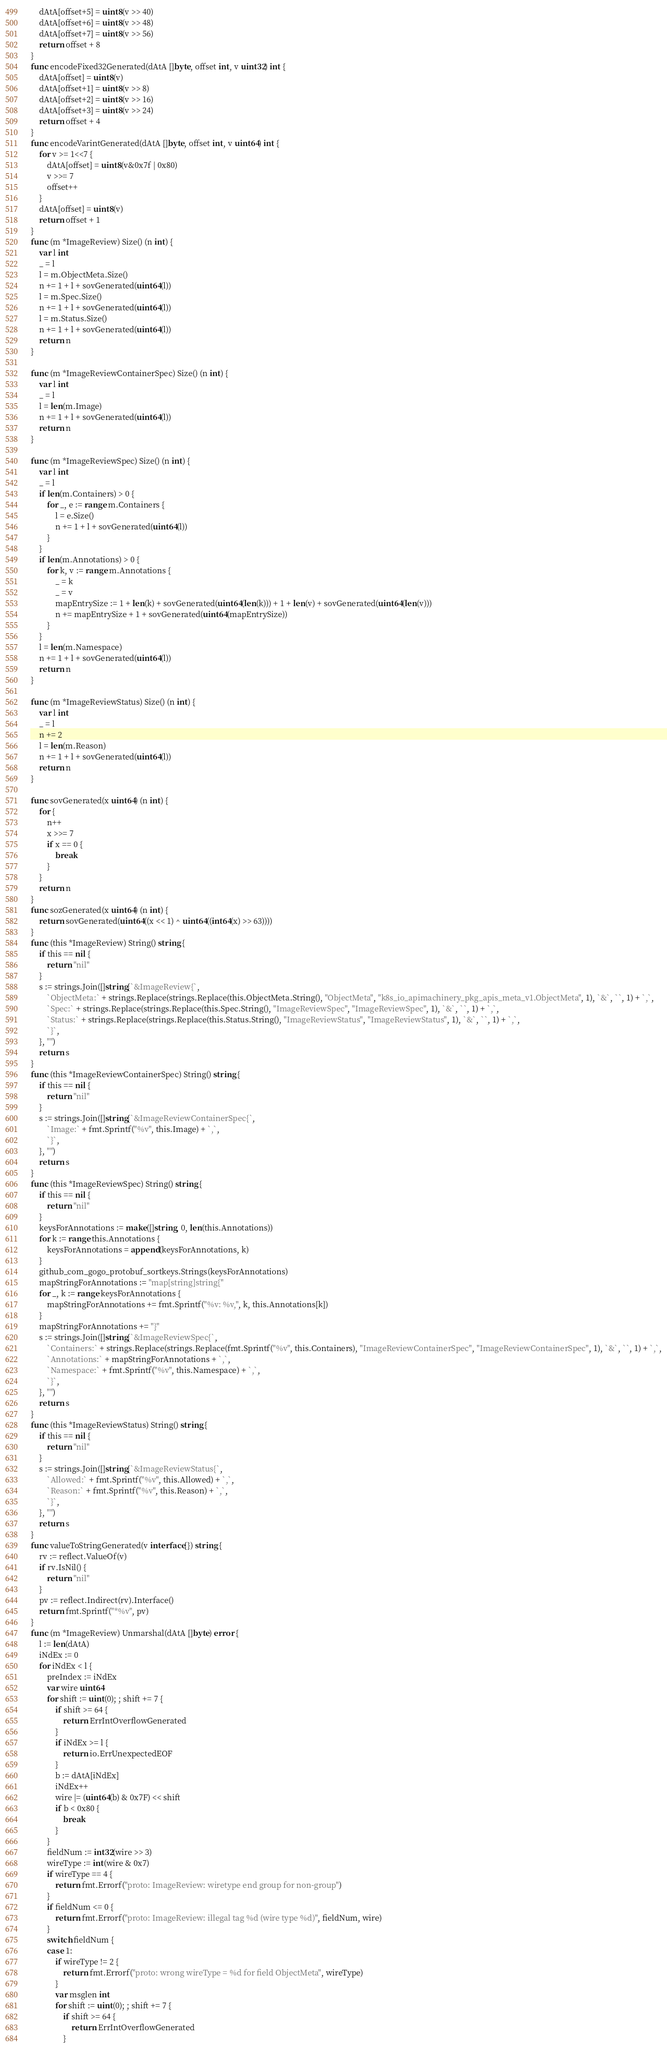<code> <loc_0><loc_0><loc_500><loc_500><_Go_>	dAtA[offset+5] = uint8(v >> 40)
	dAtA[offset+6] = uint8(v >> 48)
	dAtA[offset+7] = uint8(v >> 56)
	return offset + 8
}
func encodeFixed32Generated(dAtA []byte, offset int, v uint32) int {
	dAtA[offset] = uint8(v)
	dAtA[offset+1] = uint8(v >> 8)
	dAtA[offset+2] = uint8(v >> 16)
	dAtA[offset+3] = uint8(v >> 24)
	return offset + 4
}
func encodeVarintGenerated(dAtA []byte, offset int, v uint64) int {
	for v >= 1<<7 {
		dAtA[offset] = uint8(v&0x7f | 0x80)
		v >>= 7
		offset++
	}
	dAtA[offset] = uint8(v)
	return offset + 1
}
func (m *ImageReview) Size() (n int) {
	var l int
	_ = l
	l = m.ObjectMeta.Size()
	n += 1 + l + sovGenerated(uint64(l))
	l = m.Spec.Size()
	n += 1 + l + sovGenerated(uint64(l))
	l = m.Status.Size()
	n += 1 + l + sovGenerated(uint64(l))
	return n
}

func (m *ImageReviewContainerSpec) Size() (n int) {
	var l int
	_ = l
	l = len(m.Image)
	n += 1 + l + sovGenerated(uint64(l))
	return n
}

func (m *ImageReviewSpec) Size() (n int) {
	var l int
	_ = l
	if len(m.Containers) > 0 {
		for _, e := range m.Containers {
			l = e.Size()
			n += 1 + l + sovGenerated(uint64(l))
		}
	}
	if len(m.Annotations) > 0 {
		for k, v := range m.Annotations {
			_ = k
			_ = v
			mapEntrySize := 1 + len(k) + sovGenerated(uint64(len(k))) + 1 + len(v) + sovGenerated(uint64(len(v)))
			n += mapEntrySize + 1 + sovGenerated(uint64(mapEntrySize))
		}
	}
	l = len(m.Namespace)
	n += 1 + l + sovGenerated(uint64(l))
	return n
}

func (m *ImageReviewStatus) Size() (n int) {
	var l int
	_ = l
	n += 2
	l = len(m.Reason)
	n += 1 + l + sovGenerated(uint64(l))
	return n
}

func sovGenerated(x uint64) (n int) {
	for {
		n++
		x >>= 7
		if x == 0 {
			break
		}
	}
	return n
}
func sozGenerated(x uint64) (n int) {
	return sovGenerated(uint64((x << 1) ^ uint64((int64(x) >> 63))))
}
func (this *ImageReview) String() string {
	if this == nil {
		return "nil"
	}
	s := strings.Join([]string{`&ImageReview{`,
		`ObjectMeta:` + strings.Replace(strings.Replace(this.ObjectMeta.String(), "ObjectMeta", "k8s_io_apimachinery_pkg_apis_meta_v1.ObjectMeta", 1), `&`, ``, 1) + `,`,
		`Spec:` + strings.Replace(strings.Replace(this.Spec.String(), "ImageReviewSpec", "ImageReviewSpec", 1), `&`, ``, 1) + `,`,
		`Status:` + strings.Replace(strings.Replace(this.Status.String(), "ImageReviewStatus", "ImageReviewStatus", 1), `&`, ``, 1) + `,`,
		`}`,
	}, "")
	return s
}
func (this *ImageReviewContainerSpec) String() string {
	if this == nil {
		return "nil"
	}
	s := strings.Join([]string{`&ImageReviewContainerSpec{`,
		`Image:` + fmt.Sprintf("%v", this.Image) + `,`,
		`}`,
	}, "")
	return s
}
func (this *ImageReviewSpec) String() string {
	if this == nil {
		return "nil"
	}
	keysForAnnotations := make([]string, 0, len(this.Annotations))
	for k := range this.Annotations {
		keysForAnnotations = append(keysForAnnotations, k)
	}
	github_com_gogo_protobuf_sortkeys.Strings(keysForAnnotations)
	mapStringForAnnotations := "map[string]string{"
	for _, k := range keysForAnnotations {
		mapStringForAnnotations += fmt.Sprintf("%v: %v,", k, this.Annotations[k])
	}
	mapStringForAnnotations += "}"
	s := strings.Join([]string{`&ImageReviewSpec{`,
		`Containers:` + strings.Replace(strings.Replace(fmt.Sprintf("%v", this.Containers), "ImageReviewContainerSpec", "ImageReviewContainerSpec", 1), `&`, ``, 1) + `,`,
		`Annotations:` + mapStringForAnnotations + `,`,
		`Namespace:` + fmt.Sprintf("%v", this.Namespace) + `,`,
		`}`,
	}, "")
	return s
}
func (this *ImageReviewStatus) String() string {
	if this == nil {
		return "nil"
	}
	s := strings.Join([]string{`&ImageReviewStatus{`,
		`Allowed:` + fmt.Sprintf("%v", this.Allowed) + `,`,
		`Reason:` + fmt.Sprintf("%v", this.Reason) + `,`,
		`}`,
	}, "")
	return s
}
func valueToStringGenerated(v interface{}) string {
	rv := reflect.ValueOf(v)
	if rv.IsNil() {
		return "nil"
	}
	pv := reflect.Indirect(rv).Interface()
	return fmt.Sprintf("*%v", pv)
}
func (m *ImageReview) Unmarshal(dAtA []byte) error {
	l := len(dAtA)
	iNdEx := 0
	for iNdEx < l {
		preIndex := iNdEx
		var wire uint64
		for shift := uint(0); ; shift += 7 {
			if shift >= 64 {
				return ErrIntOverflowGenerated
			}
			if iNdEx >= l {
				return io.ErrUnexpectedEOF
			}
			b := dAtA[iNdEx]
			iNdEx++
			wire |= (uint64(b) & 0x7F) << shift
			if b < 0x80 {
				break
			}
		}
		fieldNum := int32(wire >> 3)
		wireType := int(wire & 0x7)
		if wireType == 4 {
			return fmt.Errorf("proto: ImageReview: wiretype end group for non-group")
		}
		if fieldNum <= 0 {
			return fmt.Errorf("proto: ImageReview: illegal tag %d (wire type %d)", fieldNum, wire)
		}
		switch fieldNum {
		case 1:
			if wireType != 2 {
				return fmt.Errorf("proto: wrong wireType = %d for field ObjectMeta", wireType)
			}
			var msglen int
			for shift := uint(0); ; shift += 7 {
				if shift >= 64 {
					return ErrIntOverflowGenerated
				}</code> 